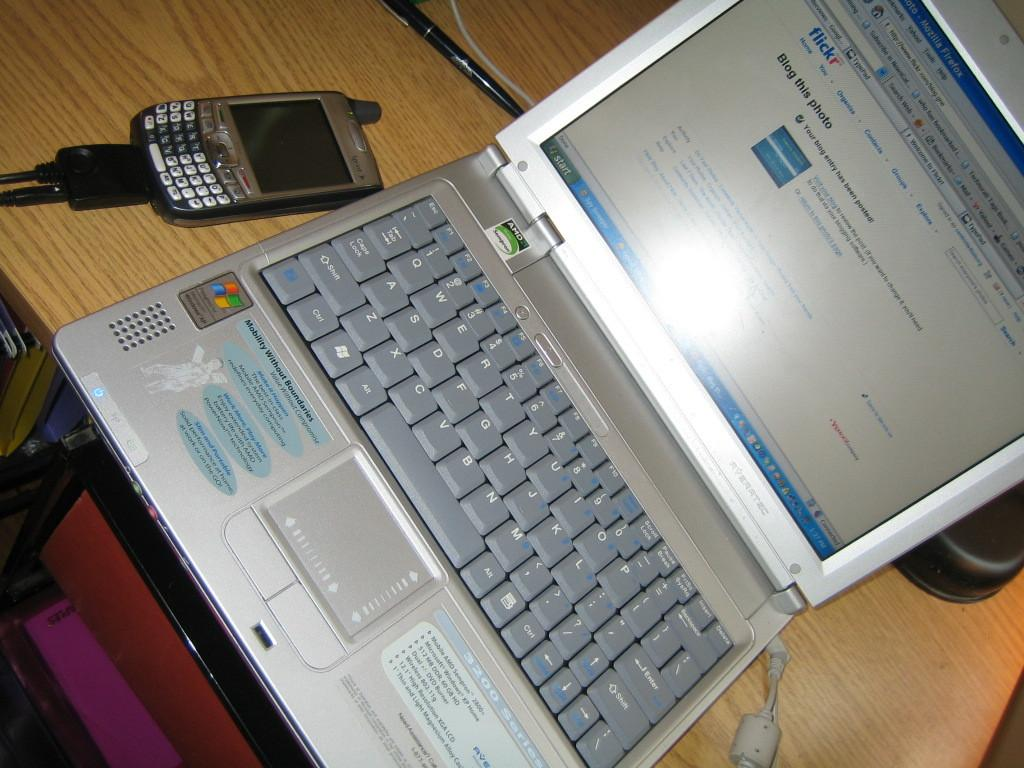<image>
Present a compact description of the photo's key features. An open laptop showing a flickr web page next to a Sprint cellphone 